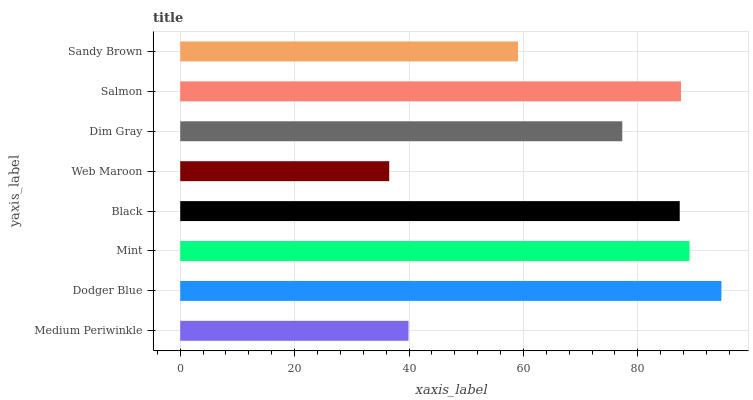Is Web Maroon the minimum?
Answer yes or no. Yes. Is Dodger Blue the maximum?
Answer yes or no. Yes. Is Mint the minimum?
Answer yes or no. No. Is Mint the maximum?
Answer yes or no. No. Is Dodger Blue greater than Mint?
Answer yes or no. Yes. Is Mint less than Dodger Blue?
Answer yes or no. Yes. Is Mint greater than Dodger Blue?
Answer yes or no. No. Is Dodger Blue less than Mint?
Answer yes or no. No. Is Black the high median?
Answer yes or no. Yes. Is Dim Gray the low median?
Answer yes or no. Yes. Is Dodger Blue the high median?
Answer yes or no. No. Is Dodger Blue the low median?
Answer yes or no. No. 